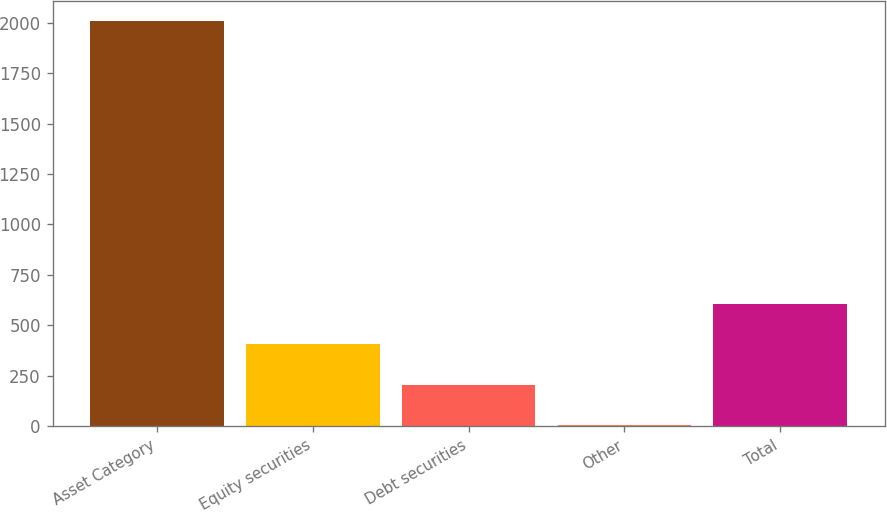Convert chart to OTSL. <chart><loc_0><loc_0><loc_500><loc_500><bar_chart><fcel>Asset Category<fcel>Equity securities<fcel>Debt securities<fcel>Other<fcel>Total<nl><fcel>2007<fcel>405.88<fcel>205.74<fcel>5.6<fcel>606.02<nl></chart> 